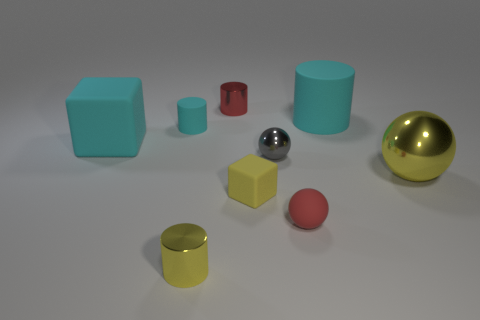Subtract all small metallic spheres. How many spheres are left? 2 Add 1 big yellow metallic spheres. How many objects exist? 10 Subtract all yellow blocks. How many blocks are left? 1 Subtract all purple spheres. How many cyan cylinders are left? 2 Subtract 2 cylinders. How many cylinders are left? 2 Subtract all cubes. How many objects are left? 7 Add 4 small brown objects. How many small brown objects exist? 4 Subtract 1 red cylinders. How many objects are left? 8 Subtract all yellow cubes. Subtract all yellow spheres. How many cubes are left? 1 Subtract all small green metallic cylinders. Subtract all red balls. How many objects are left? 8 